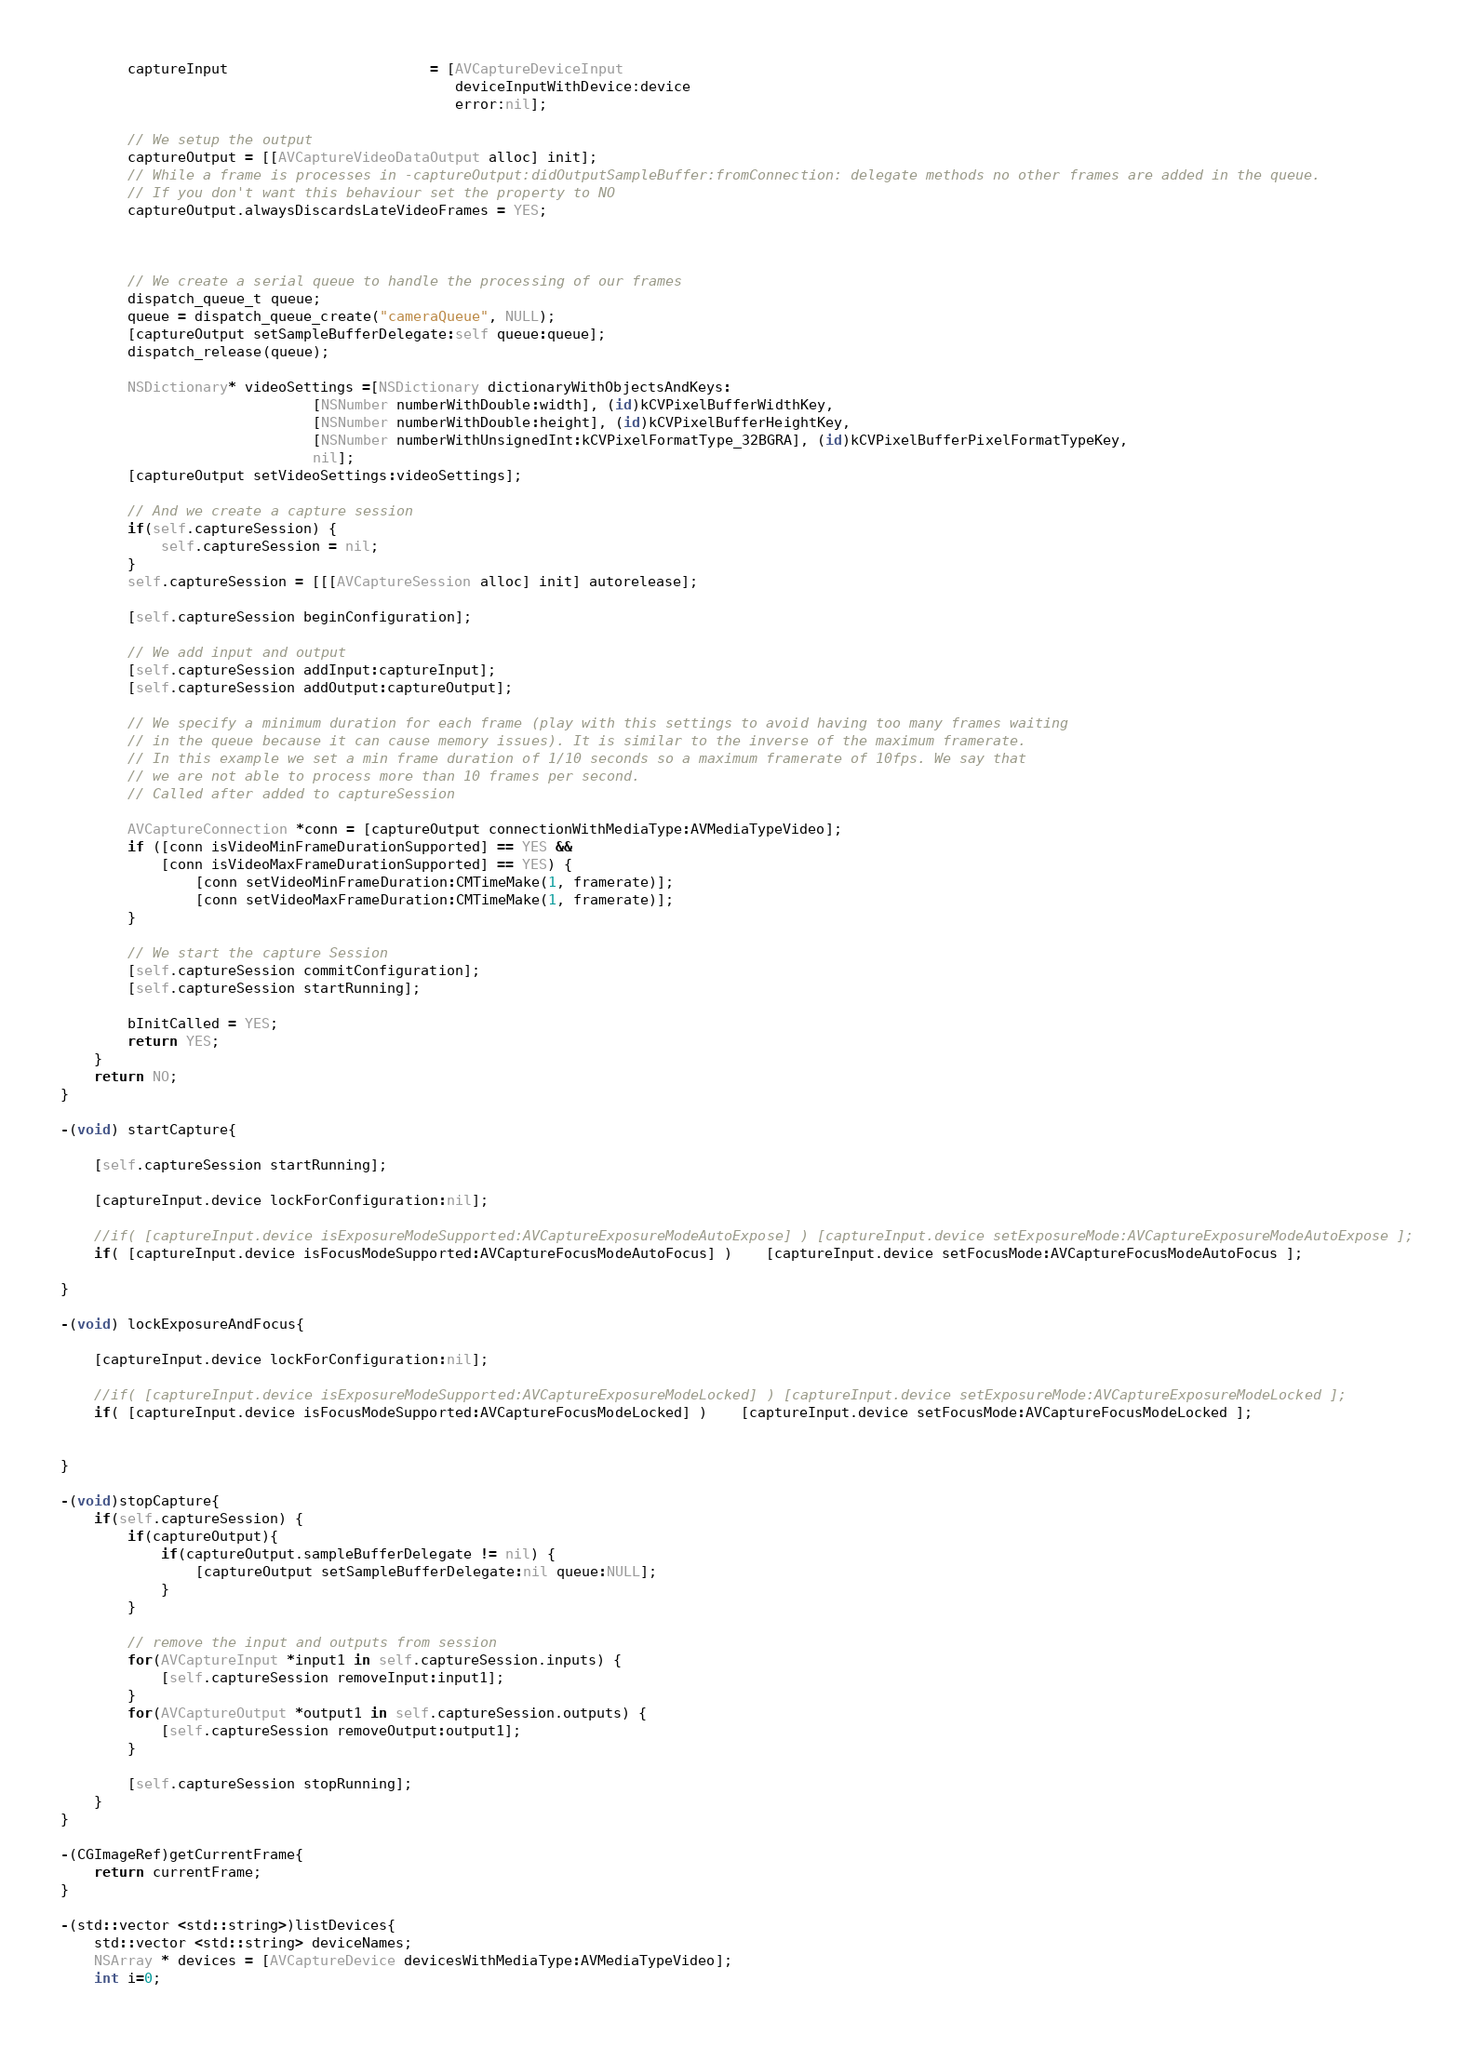<code> <loc_0><loc_0><loc_500><loc_500><_ObjectiveC_>		captureInput						= [AVCaptureDeviceInput
											   deviceInputWithDevice:device
											   error:nil];

		// We setup the output
		captureOutput = [[AVCaptureVideoDataOutput alloc] init];
		// While a frame is processes in -captureOutput:didOutputSampleBuffer:fromConnection: delegate methods no other frames are added in the queue.
		// If you don't want this behaviour set the property to NO
		captureOutput.alwaysDiscardsLateVideoFrames = YES;



		// We create a serial queue to handle the processing of our frames
		dispatch_queue_t queue;
		queue = dispatch_queue_create("cameraQueue", NULL);
		[captureOutput setSampleBufferDelegate:self queue:queue];
		dispatch_release(queue);

		NSDictionary* videoSettings =[NSDictionary dictionaryWithObjectsAndKeys:
                              [NSNumber numberWithDouble:width], (id)kCVPixelBufferWidthKey,
                              [NSNumber numberWithDouble:height], (id)kCVPixelBufferHeightKey,
                              [NSNumber numberWithUnsignedInt:kCVPixelFormatType_32BGRA], (id)kCVPixelBufferPixelFormatTypeKey,
                              nil];
		[captureOutput setVideoSettings:videoSettings];

		// And we create a capture session
		if(self.captureSession) {
			self.captureSession = nil;
		}
		self.captureSession = [[[AVCaptureSession alloc] init] autorelease];

		[self.captureSession beginConfiguration];

		// We add input and output
		[self.captureSession addInput:captureInput];
		[self.captureSession addOutput:captureOutput];

		// We specify a minimum duration for each frame (play with this settings to avoid having too many frames waiting
		// in the queue because it can cause memory issues). It is similar to the inverse of the maximum framerate.
		// In this example we set a min frame duration of 1/10 seconds so a maximum framerate of 10fps. We say that
		// we are not able to process more than 10 frames per second.
		// Called after added to captureSession

		AVCaptureConnection *conn = [captureOutput connectionWithMediaType:AVMediaTypeVideo];
		if ([conn isVideoMinFrameDurationSupported] == YES &&
			[conn isVideoMaxFrameDurationSupported] == YES) {
				[conn setVideoMinFrameDuration:CMTimeMake(1, framerate)];
				[conn setVideoMaxFrameDuration:CMTimeMake(1, framerate)];
		}

		// We start the capture Session
		[self.captureSession commitConfiguration];
		[self.captureSession startRunning];

		bInitCalled = YES;
		return YES;
	}
	return NO;
}

-(void) startCapture{

	[self.captureSession startRunning];

	[captureInput.device lockForConfiguration:nil];

	//if( [captureInput.device isExposureModeSupported:AVCaptureExposureModeAutoExpose] ) [captureInput.device setExposureMode:AVCaptureExposureModeAutoExpose ];
	if( [captureInput.device isFocusModeSupported:AVCaptureFocusModeAutoFocus] )	[captureInput.device setFocusMode:AVCaptureFocusModeAutoFocus ];

}

-(void) lockExposureAndFocus{

	[captureInput.device lockForConfiguration:nil];

	//if( [captureInput.device isExposureModeSupported:AVCaptureExposureModeLocked] ) [captureInput.device setExposureMode:AVCaptureExposureModeLocked ];
	if( [captureInput.device isFocusModeSupported:AVCaptureFocusModeLocked] )	[captureInput.device setFocusMode:AVCaptureFocusModeLocked ];


}

-(void)stopCapture{
	if(self.captureSession) {
		if(captureOutput){
			if(captureOutput.sampleBufferDelegate != nil) {
				[captureOutput setSampleBufferDelegate:nil queue:NULL];
			}
		}

		// remove the input and outputs from session
		for(AVCaptureInput *input1 in self.captureSession.inputs) {
		    [self.captureSession removeInput:input1];
		}
		for(AVCaptureOutput *output1 in self.captureSession.outputs) {
		    [self.captureSession removeOutput:output1];
		}

		[self.captureSession stopRunning];
	}
}

-(CGImageRef)getCurrentFrame{
	return currentFrame;
}

-(std::vector <std::string>)listDevices{
    std::vector <std::string> deviceNames;
	NSArray * devices = [AVCaptureDevice devicesWithMediaType:AVMediaTypeVideo];
	int i=0;</code> 